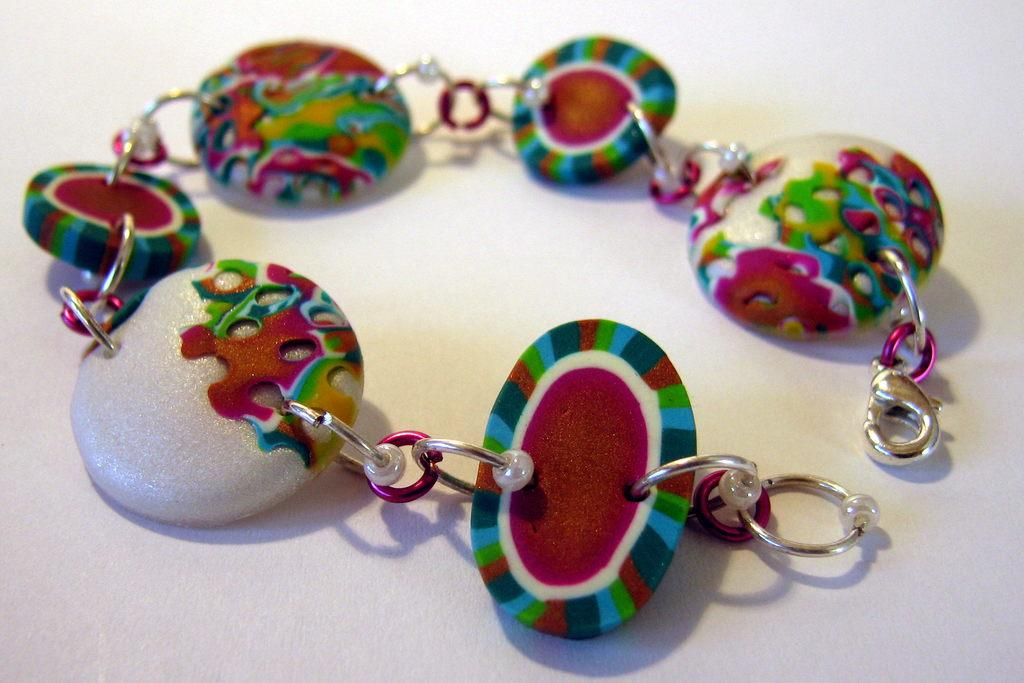What is the main object in the image? There is a bracelet in the image. What are the beads on the bracelet made of? The bracelet has beads, but the material is not specified in the facts. On what surface is the bracelet placed? The bracelet is placed on a white surface. What type of railway can be seen in the image? There is no railway present in the image; it features a bracelet with beads placed on a white surface. How many fingers are touching the bracelet in the image? The facts do not mention any fingers touching the bracelet, so it cannot be determined from the image. 